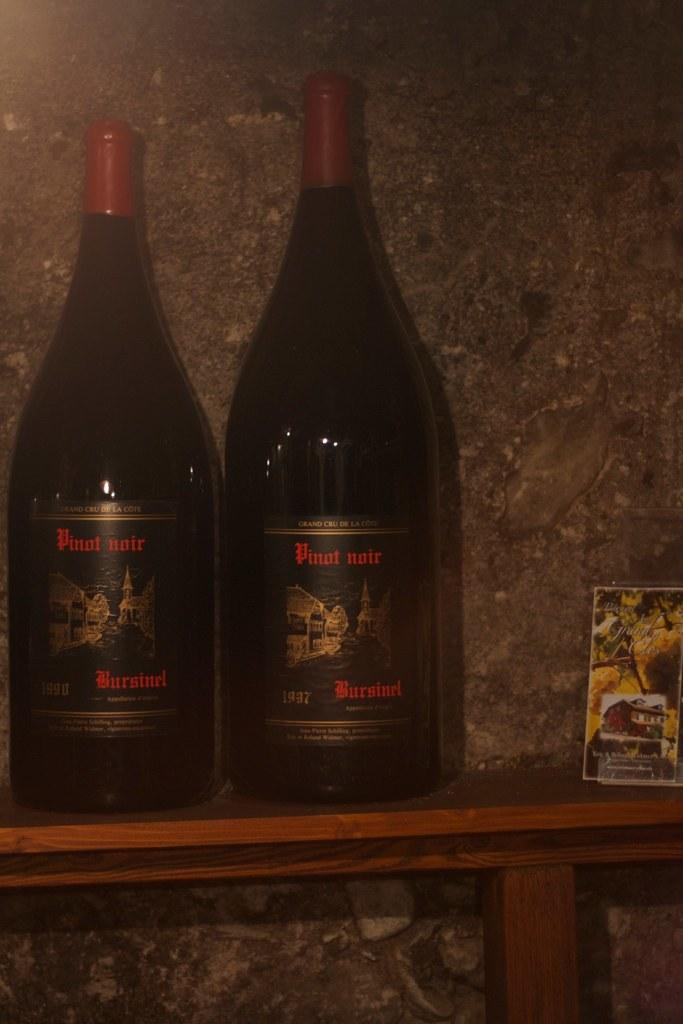<image>
Describe the image concisely. Two different sized bottles of Bursinel pinot noir. 